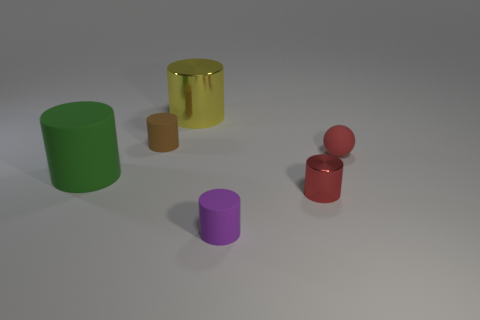Can you describe the materials of all cylinders shown in the image? Certainly! The image displays three cylinders, each made of distinct materials. The large cylinder on the left is metallic, which you can tell by its reflective surface and smooth texture. The middle cylinder is smaller and has an opaque, possibly rubber-like surface. The third cylinder, which is right of the others, has translucent sides and a reflective surface, suggesting it is made of glass or clear plastic. 